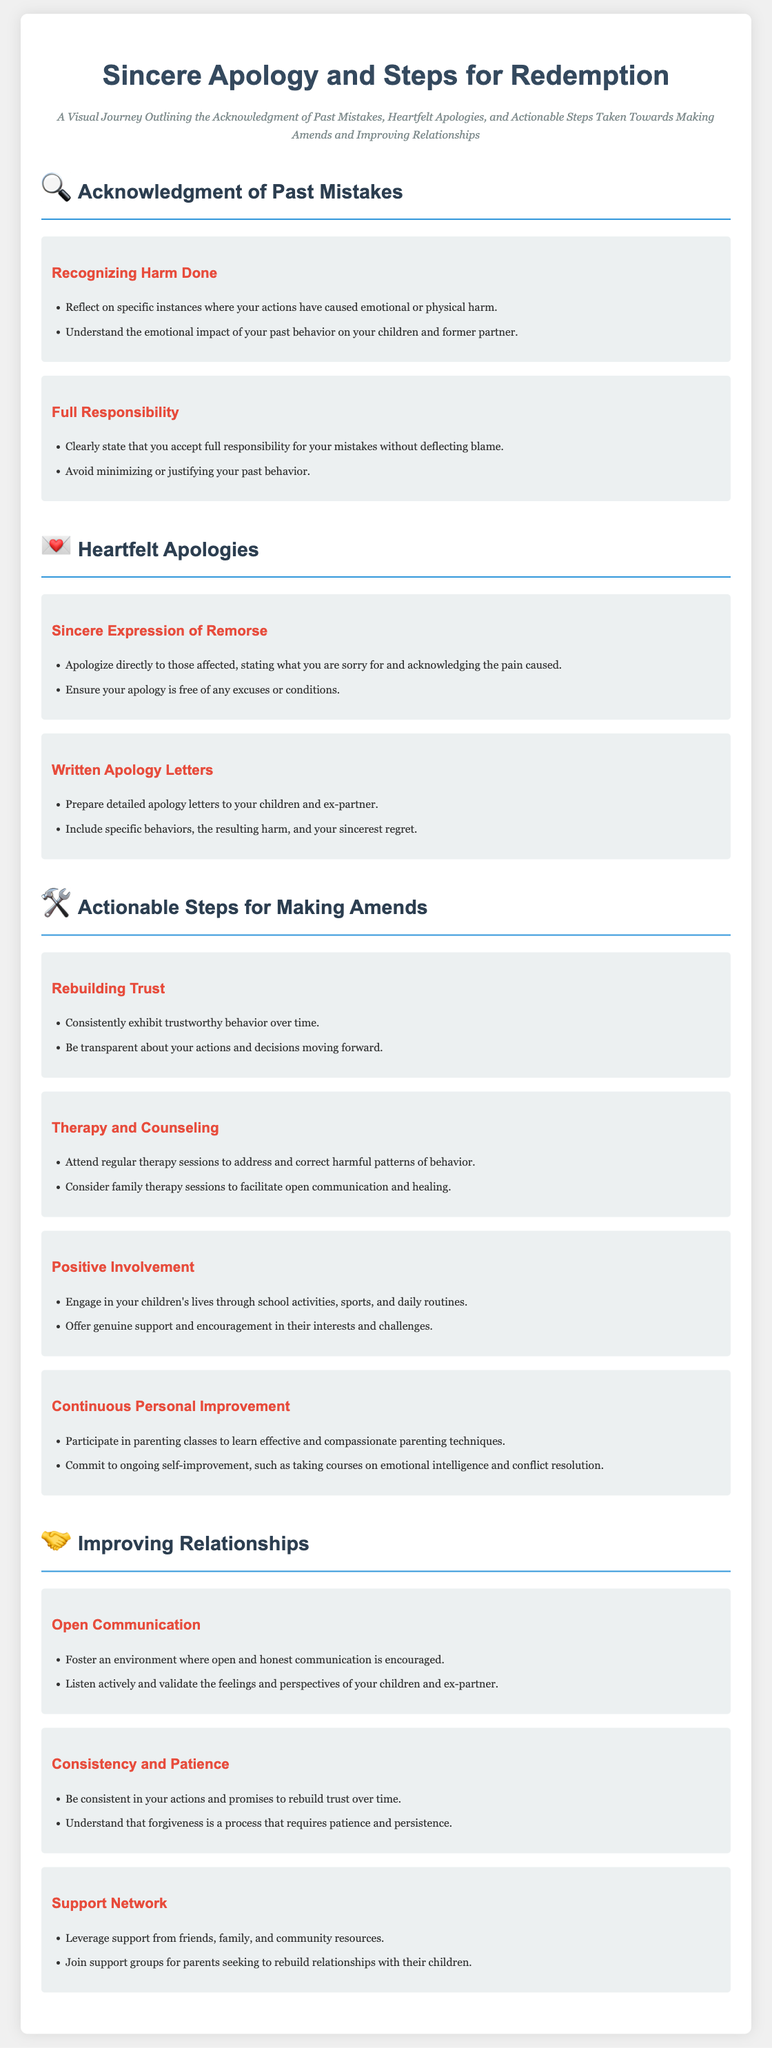What is the main title of the document? The title indicates the primary focus of the infographic, which is about apologies and redemption steps.
Answer: Sincere Apology and Steps for Redemption How many sections are in the infographic? The infographic is organized into several specific topics, each represented as a section.
Answer: Four What icon represents the section on heartfelt apologies? The icon provides a visual cue associated with the theme of that particular section.
Answer: 💌 What is the first actionable step for making amends? This step highlights initial measures one can take towards redemption and rebuilding relationships.
Answer: Rebuilding Trust What should one do before expressing a heartfelt apology? The document suggests a crucial preparatory step that leads into the act of apologizing.
Answer: Recognizing Harm Done Which group may be beneficial to join for assistance in improving relationships? This refers to external support systems that can help in the journey of making amends.
Answer: Support groups What is emphasized as necessary for forgiveness in relationships? The document outlines an essential quality that is important in the context of rebuilding trust and relationships.
Answer: Patience What therapy type may be helpful according to the document? The infographic recommends a type of professional support aimed at personal and relational improvement.
Answer: Family therapy sessions 